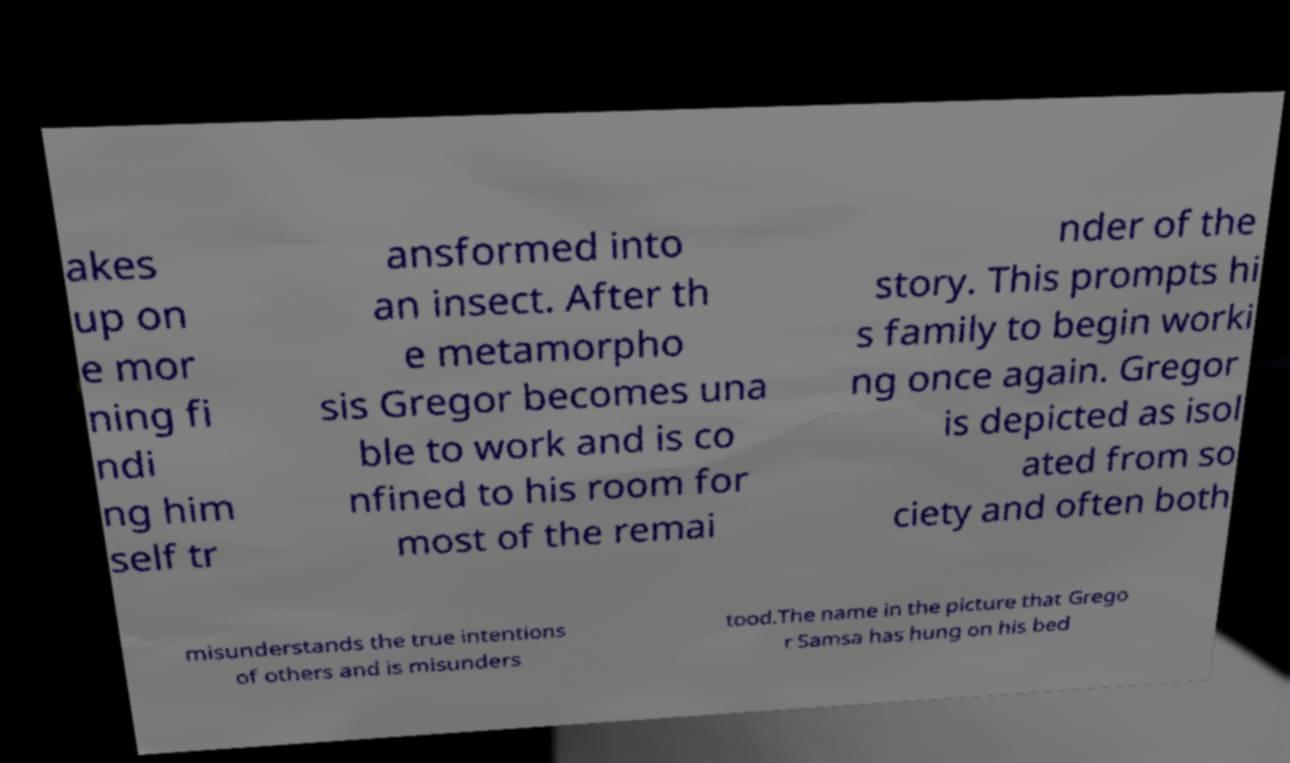Can you read and provide the text displayed in the image?This photo seems to have some interesting text. Can you extract and type it out for me? akes up on e mor ning fi ndi ng him self tr ansformed into an insect. After th e metamorpho sis Gregor becomes una ble to work and is co nfined to his room for most of the remai nder of the story. This prompts hi s family to begin worki ng once again. Gregor is depicted as isol ated from so ciety and often both misunderstands the true intentions of others and is misunders tood.The name in the picture that Grego r Samsa has hung on his bed 